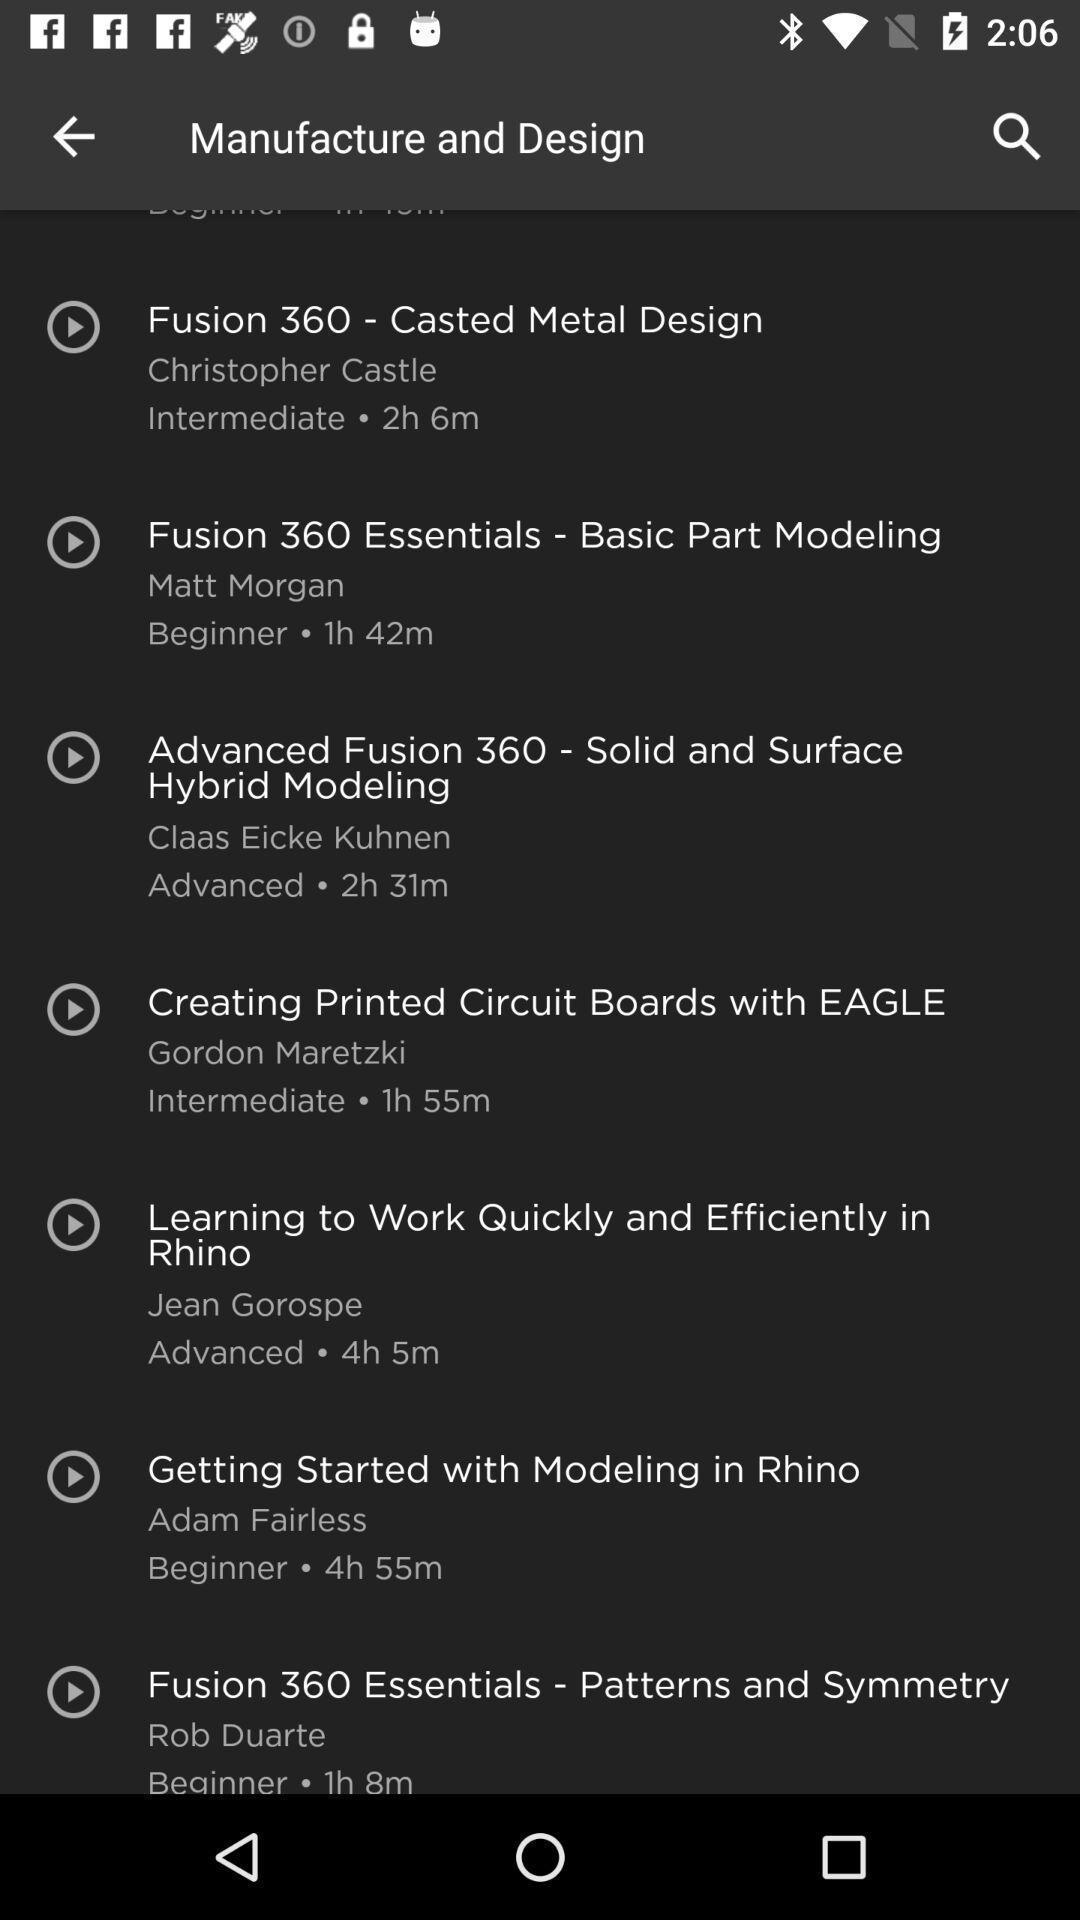Describe the visual elements of this screenshot. Screen showing some leading technology skills. 